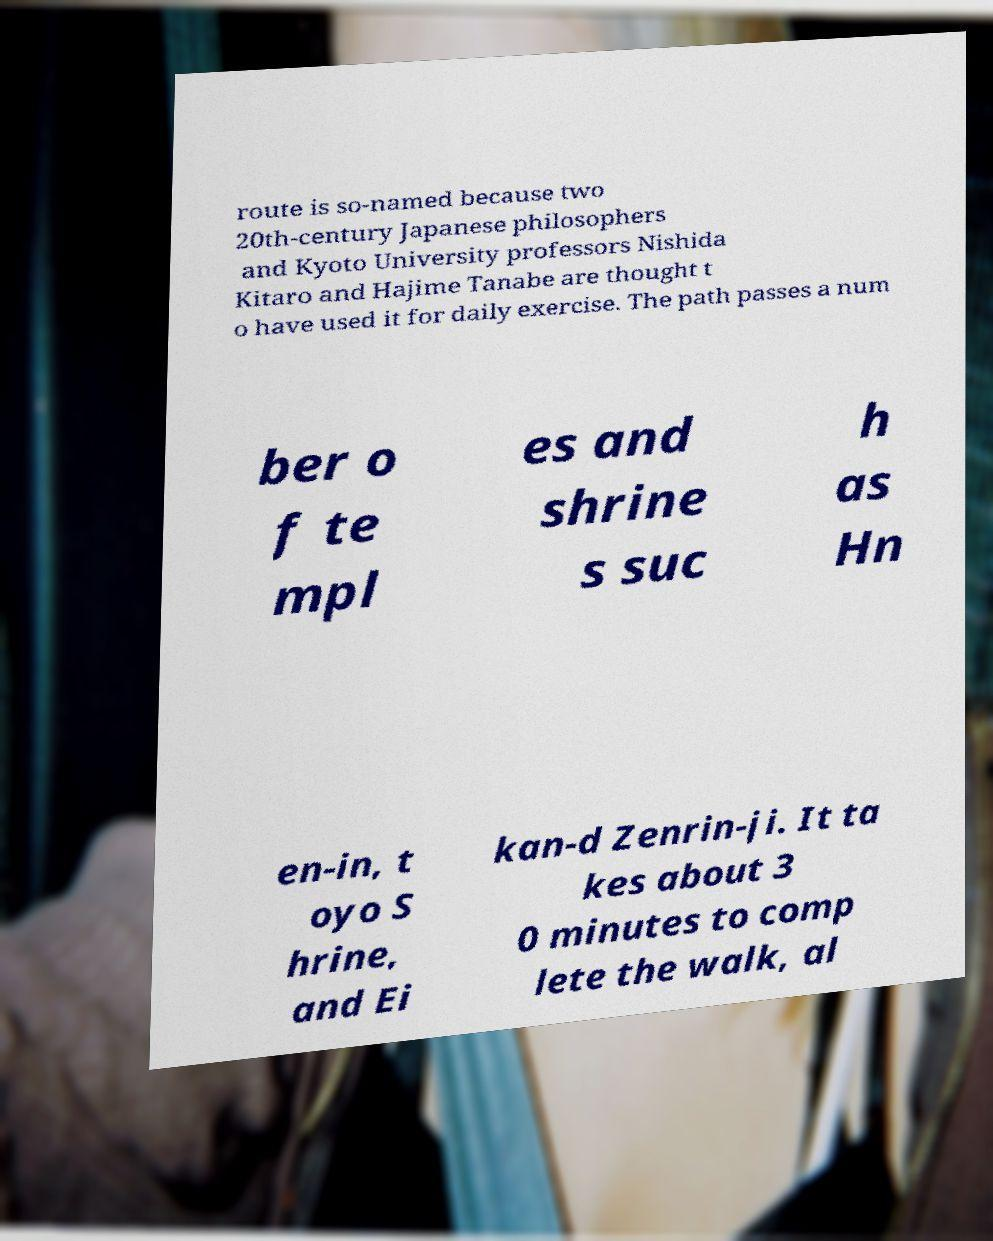For documentation purposes, I need the text within this image transcribed. Could you provide that? route is so-named because two 20th-century Japanese philosophers and Kyoto University professors Nishida Kitaro and Hajime Tanabe are thought t o have used it for daily exercise. The path passes a num ber o f te mpl es and shrine s suc h as Hn en-in, t oyo S hrine, and Ei kan-d Zenrin-ji. It ta kes about 3 0 minutes to comp lete the walk, al 